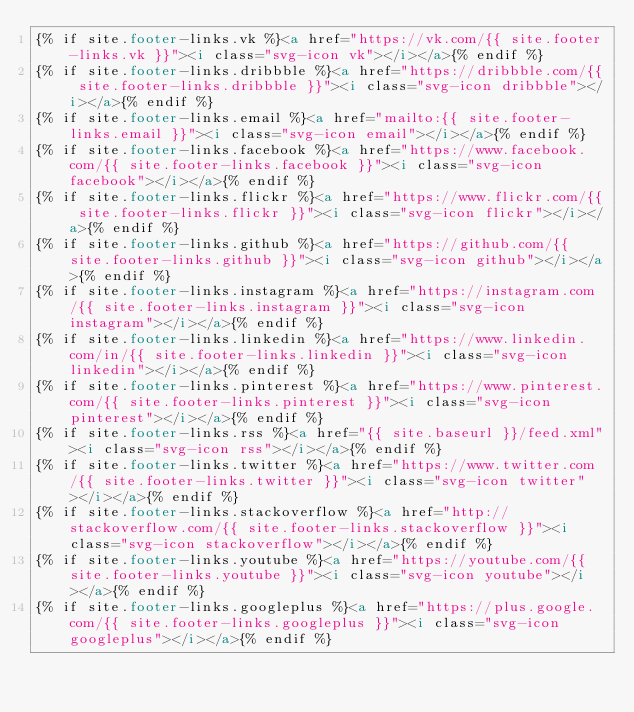<code> <loc_0><loc_0><loc_500><loc_500><_HTML_>{% if site.footer-links.vk %}<a href="https://vk.com/{{ site.footer-links.vk }}"><i class="svg-icon vk"></i></a>{% endif %}
{% if site.footer-links.dribbble %}<a href="https://dribbble.com/{{ site.footer-links.dribbble }}"><i class="svg-icon dribbble"></i></a>{% endif %}
{% if site.footer-links.email %}<a href="mailto:{{ site.footer-links.email }}"><i class="svg-icon email"></i></a>{% endif %}
{% if site.footer-links.facebook %}<a href="https://www.facebook.com/{{ site.footer-links.facebook }}"><i class="svg-icon facebook"></i></a>{% endif %}
{% if site.footer-links.flickr %}<a href="https://www.flickr.com/{{ site.footer-links.flickr }}"><i class="svg-icon flickr"></i></a>{% endif %}
{% if site.footer-links.github %}<a href="https://github.com/{{ site.footer-links.github }}"><i class="svg-icon github"></i></a>{% endif %}
{% if site.footer-links.instagram %}<a href="https://instagram.com/{{ site.footer-links.instagram }}"><i class="svg-icon instagram"></i></a>{% endif %}
{% if site.footer-links.linkedin %}<a href="https://www.linkedin.com/in/{{ site.footer-links.linkedin }}"><i class="svg-icon linkedin"></i></a>{% endif %}
{% if site.footer-links.pinterest %}<a href="https://www.pinterest.com/{{ site.footer-links.pinterest }}"><i class="svg-icon pinterest"></i></a>{% endif %}
{% if site.footer-links.rss %}<a href="{{ site.baseurl }}/feed.xml"><i class="svg-icon rss"></i></a>{% endif %}
{% if site.footer-links.twitter %}<a href="https://www.twitter.com/{{ site.footer-links.twitter }}"><i class="svg-icon twitter"></i></a>{% endif %}
{% if site.footer-links.stackoverflow %}<a href="http://stackoverflow.com/{{ site.footer-links.stackoverflow }}"><i class="svg-icon stackoverflow"></i></a>{% endif %}
{% if site.footer-links.youtube %}<a href="https://youtube.com/{{ site.footer-links.youtube }}"><i class="svg-icon youtube"></i></a>{% endif %}
{% if site.footer-links.googleplus %}<a href="https://plus.google.com/{{ site.footer-links.googleplus }}"><i class="svg-icon googleplus"></i></a>{% endif %}


</code> 